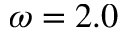Convert formula to latex. <formula><loc_0><loc_0><loc_500><loc_500>\omega = 2 . 0</formula> 